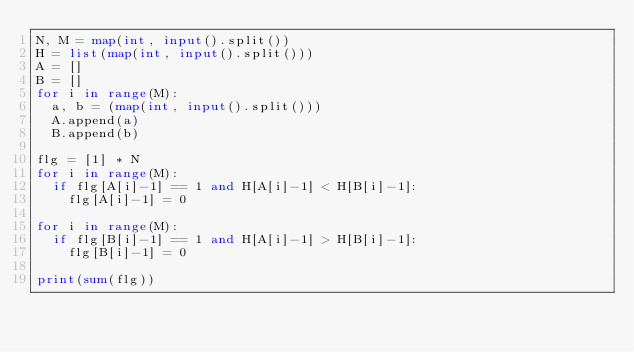<code> <loc_0><loc_0><loc_500><loc_500><_Python_>N, M = map(int, input().split())
H = list(map(int, input().split()))
A = []
B = []
for i in range(M):
  a, b = (map(int, input().split()))
  A.append(a)
  B.append(b)

flg = [1] * N
for i in range(M):
  if flg[A[i]-1] == 1 and H[A[i]-1] < H[B[i]-1]:
    flg[A[i]-1] = 0

for i in range(M):
  if flg[B[i]-1] == 1 and H[A[i]-1] > H[B[i]-1]:
    flg[B[i]-1] = 0

print(sum(flg))</code> 